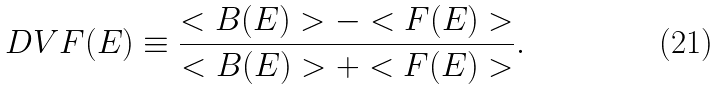Convert formula to latex. <formula><loc_0><loc_0><loc_500><loc_500>D V F ( E ) \equiv \frac { < B ( E ) > - < F ( E ) > } { < B ( E ) > + < F ( E ) > } .</formula> 